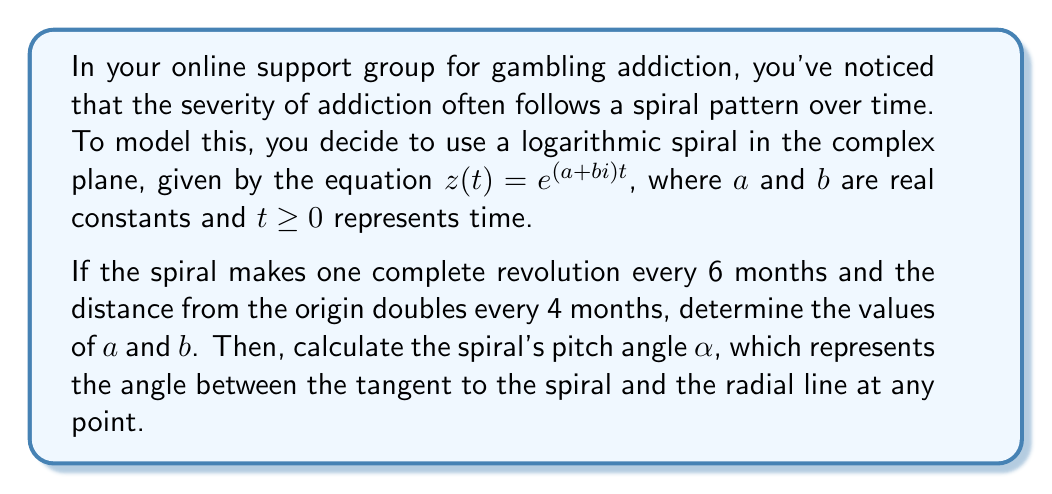What is the answer to this math problem? Let's approach this step-by-step:

1) For a logarithmic spiral $z(t) = e^{(a+bi)t}$, we know that:
   - $a$ determines the rate of growth or decay of the spiral
   - $b$ determines the rate of rotation

2) One complete revolution occurs when the imaginary part of the exponent changes by $2\pi$. So:
   $bt = 2\pi$ when $t = 6$ (6 months)
   Therefore, $b = \frac{2\pi}{6} = \frac{\pi}{3}$

3) The distance from the origin doubles every 4 months. This means:
   $|e^{(a+bi)t}| = e^{at} = 2$ when $t = 4$
   Taking the natural log of both sides:
   $at = \ln(2)$ when $t = 4$
   Therefore, $a = \frac{\ln(2)}{4}$

4) Now we have $a = \frac{\ln(2)}{4}$ and $b = \frac{\pi}{3}$

5) The pitch angle $\alpha$ of a logarithmic spiral is given by:
   $\alpha = \arctan(\frac{a}{b})$

6) Substituting our values:
   $\alpha = \arctan(\frac{\frac{\ln(2)}{4}}{\frac{\pi}{3}}) = \arctan(\frac{3\ln(2)}{4\pi})$
Answer: $a = \frac{\ln(2)}{4}$, $b = \frac{\pi}{3}$, and $\alpha = \arctan(\frac{3\ln(2)}{4\pi}) \approx 0.2318$ radians or $13.28°$ 